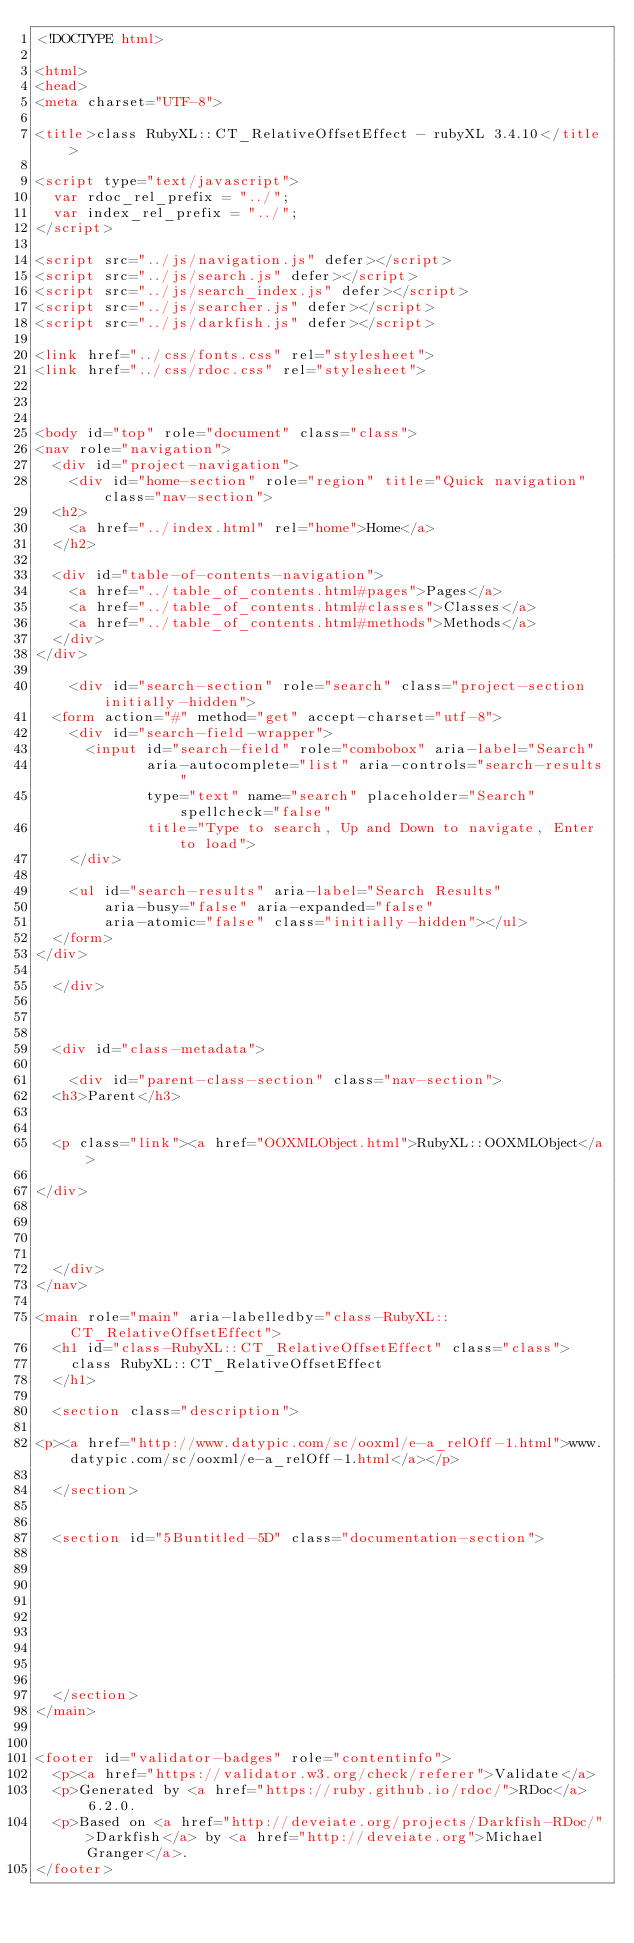<code> <loc_0><loc_0><loc_500><loc_500><_HTML_><!DOCTYPE html>

<html>
<head>
<meta charset="UTF-8">

<title>class RubyXL::CT_RelativeOffsetEffect - rubyXL 3.4.10</title>

<script type="text/javascript">
  var rdoc_rel_prefix = "../";
  var index_rel_prefix = "../";
</script>

<script src="../js/navigation.js" defer></script>
<script src="../js/search.js" defer></script>
<script src="../js/search_index.js" defer></script>
<script src="../js/searcher.js" defer></script>
<script src="../js/darkfish.js" defer></script>

<link href="../css/fonts.css" rel="stylesheet">
<link href="../css/rdoc.css" rel="stylesheet">



<body id="top" role="document" class="class">
<nav role="navigation">
  <div id="project-navigation">
    <div id="home-section" role="region" title="Quick navigation" class="nav-section">
  <h2>
    <a href="../index.html" rel="home">Home</a>
  </h2>

  <div id="table-of-contents-navigation">
    <a href="../table_of_contents.html#pages">Pages</a>
    <a href="../table_of_contents.html#classes">Classes</a>
    <a href="../table_of_contents.html#methods">Methods</a>
  </div>
</div>

    <div id="search-section" role="search" class="project-section initially-hidden">
  <form action="#" method="get" accept-charset="utf-8">
    <div id="search-field-wrapper">
      <input id="search-field" role="combobox" aria-label="Search"
             aria-autocomplete="list" aria-controls="search-results"
             type="text" name="search" placeholder="Search" spellcheck="false"
             title="Type to search, Up and Down to navigate, Enter to load">
    </div>

    <ul id="search-results" aria-label="Search Results"
        aria-busy="false" aria-expanded="false"
        aria-atomic="false" class="initially-hidden"></ul>
  </form>
</div>

  </div>

  

  <div id="class-metadata">
    
    <div id="parent-class-section" class="nav-section">
  <h3>Parent</h3>

  
  <p class="link"><a href="OOXMLObject.html">RubyXL::OOXMLObject</a>
  
</div>

    
    
    
  </div>
</nav>

<main role="main" aria-labelledby="class-RubyXL::CT_RelativeOffsetEffect">
  <h1 id="class-RubyXL::CT_RelativeOffsetEffect" class="class">
    class RubyXL::CT_RelativeOffsetEffect
  </h1>

  <section class="description">
    
<p><a href="http://www.datypic.com/sc/ooxml/e-a_relOff-1.html">www.datypic.com/sc/ooxml/e-a_relOff-1.html</a></p>

  </section>

  
  <section id="5Buntitled-5D" class="documentation-section">
    

    

    

    

    
  </section>
</main>


<footer id="validator-badges" role="contentinfo">
  <p><a href="https://validator.w3.org/check/referer">Validate</a>
  <p>Generated by <a href="https://ruby.github.io/rdoc/">RDoc</a> 6.2.0.
  <p>Based on <a href="http://deveiate.org/projects/Darkfish-RDoc/">Darkfish</a> by <a href="http://deveiate.org">Michael Granger</a>.
</footer>

</code> 